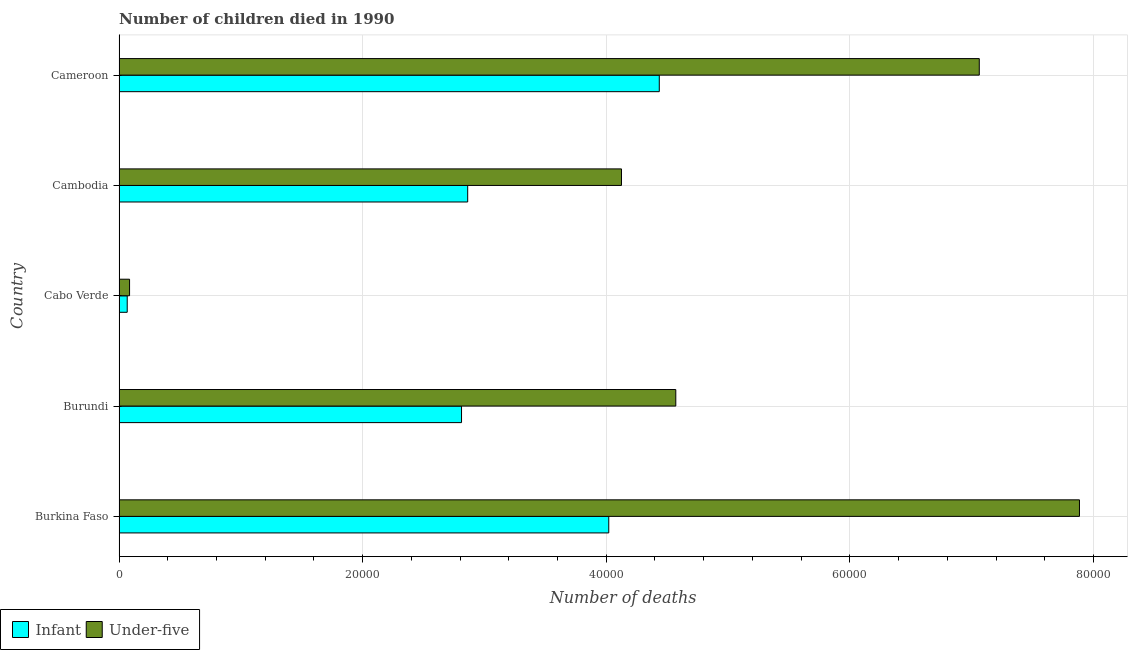How many groups of bars are there?
Your answer should be very brief. 5. Are the number of bars on each tick of the Y-axis equal?
Keep it short and to the point. Yes. What is the label of the 4th group of bars from the top?
Your answer should be very brief. Burundi. In how many cases, is the number of bars for a given country not equal to the number of legend labels?
Make the answer very short. 0. What is the number of infant deaths in Burundi?
Ensure brevity in your answer.  2.81e+04. Across all countries, what is the maximum number of under-five deaths?
Provide a succinct answer. 7.88e+04. Across all countries, what is the minimum number of infant deaths?
Offer a terse response. 671. In which country was the number of under-five deaths maximum?
Your answer should be compact. Burkina Faso. In which country was the number of under-five deaths minimum?
Your answer should be compact. Cabo Verde. What is the total number of infant deaths in the graph?
Ensure brevity in your answer.  1.42e+05. What is the difference between the number of under-five deaths in Burundi and that in Cambodia?
Offer a terse response. 4459. What is the difference between the number of under-five deaths in Burundi and the number of infant deaths in Cabo Verde?
Your response must be concise. 4.50e+04. What is the average number of infant deaths per country?
Your answer should be compact. 2.84e+04. What is the difference between the number of under-five deaths and number of infant deaths in Cambodia?
Give a very brief answer. 1.26e+04. In how many countries, is the number of infant deaths greater than 28000 ?
Provide a succinct answer. 4. What is the ratio of the number of infant deaths in Burkina Faso to that in Cameroon?
Make the answer very short. 0.91. Is the number of infant deaths in Burkina Faso less than that in Cambodia?
Your answer should be compact. No. Is the difference between the number of under-five deaths in Burkina Faso and Cabo Verde greater than the difference between the number of infant deaths in Burkina Faso and Cabo Verde?
Your response must be concise. Yes. What is the difference between the highest and the second highest number of under-five deaths?
Ensure brevity in your answer.  8226. What is the difference between the highest and the lowest number of under-five deaths?
Ensure brevity in your answer.  7.80e+04. What does the 1st bar from the top in Burundi represents?
Offer a terse response. Under-five. What does the 2nd bar from the bottom in Burkina Faso represents?
Ensure brevity in your answer.  Under-five. How many bars are there?
Provide a short and direct response. 10. Are all the bars in the graph horizontal?
Offer a very short reply. Yes. How many countries are there in the graph?
Ensure brevity in your answer.  5. Are the values on the major ticks of X-axis written in scientific E-notation?
Provide a succinct answer. No. Does the graph contain grids?
Make the answer very short. Yes. Where does the legend appear in the graph?
Your answer should be compact. Bottom left. What is the title of the graph?
Offer a very short reply. Number of children died in 1990. What is the label or title of the X-axis?
Your response must be concise. Number of deaths. What is the label or title of the Y-axis?
Keep it short and to the point. Country. What is the Number of deaths of Infant in Burkina Faso?
Give a very brief answer. 4.02e+04. What is the Number of deaths of Under-five in Burkina Faso?
Make the answer very short. 7.88e+04. What is the Number of deaths of Infant in Burundi?
Give a very brief answer. 2.81e+04. What is the Number of deaths in Under-five in Burundi?
Keep it short and to the point. 4.57e+04. What is the Number of deaths of Infant in Cabo Verde?
Give a very brief answer. 671. What is the Number of deaths of Under-five in Cabo Verde?
Make the answer very short. 863. What is the Number of deaths of Infant in Cambodia?
Your answer should be compact. 2.86e+04. What is the Number of deaths in Under-five in Cambodia?
Your response must be concise. 4.12e+04. What is the Number of deaths of Infant in Cameroon?
Ensure brevity in your answer.  4.44e+04. What is the Number of deaths of Under-five in Cameroon?
Your response must be concise. 7.06e+04. Across all countries, what is the maximum Number of deaths in Infant?
Make the answer very short. 4.44e+04. Across all countries, what is the maximum Number of deaths of Under-five?
Make the answer very short. 7.88e+04. Across all countries, what is the minimum Number of deaths of Infant?
Your answer should be compact. 671. Across all countries, what is the minimum Number of deaths in Under-five?
Offer a very short reply. 863. What is the total Number of deaths of Infant in the graph?
Give a very brief answer. 1.42e+05. What is the total Number of deaths in Under-five in the graph?
Provide a succinct answer. 2.37e+05. What is the difference between the Number of deaths in Infant in Burkina Faso and that in Burundi?
Provide a short and direct response. 1.21e+04. What is the difference between the Number of deaths in Under-five in Burkina Faso and that in Burundi?
Offer a terse response. 3.31e+04. What is the difference between the Number of deaths of Infant in Burkina Faso and that in Cabo Verde?
Your answer should be compact. 3.95e+04. What is the difference between the Number of deaths in Under-five in Burkina Faso and that in Cabo Verde?
Your answer should be very brief. 7.80e+04. What is the difference between the Number of deaths of Infant in Burkina Faso and that in Cambodia?
Ensure brevity in your answer.  1.16e+04. What is the difference between the Number of deaths in Under-five in Burkina Faso and that in Cambodia?
Offer a very short reply. 3.76e+04. What is the difference between the Number of deaths of Infant in Burkina Faso and that in Cameroon?
Give a very brief answer. -4148. What is the difference between the Number of deaths in Under-five in Burkina Faso and that in Cameroon?
Keep it short and to the point. 8226. What is the difference between the Number of deaths in Infant in Burundi and that in Cabo Verde?
Your response must be concise. 2.74e+04. What is the difference between the Number of deaths of Under-five in Burundi and that in Cabo Verde?
Ensure brevity in your answer.  4.48e+04. What is the difference between the Number of deaths of Infant in Burundi and that in Cambodia?
Provide a succinct answer. -505. What is the difference between the Number of deaths of Under-five in Burundi and that in Cambodia?
Give a very brief answer. 4459. What is the difference between the Number of deaths of Infant in Burundi and that in Cameroon?
Your answer should be compact. -1.62e+04. What is the difference between the Number of deaths in Under-five in Burundi and that in Cameroon?
Your answer should be very brief. -2.49e+04. What is the difference between the Number of deaths in Infant in Cabo Verde and that in Cambodia?
Ensure brevity in your answer.  -2.80e+04. What is the difference between the Number of deaths of Under-five in Cabo Verde and that in Cambodia?
Offer a terse response. -4.04e+04. What is the difference between the Number of deaths of Infant in Cabo Verde and that in Cameroon?
Provide a short and direct response. -4.37e+04. What is the difference between the Number of deaths in Under-five in Cabo Verde and that in Cameroon?
Offer a terse response. -6.98e+04. What is the difference between the Number of deaths in Infant in Cambodia and that in Cameroon?
Give a very brief answer. -1.57e+04. What is the difference between the Number of deaths in Under-five in Cambodia and that in Cameroon?
Provide a succinct answer. -2.94e+04. What is the difference between the Number of deaths of Infant in Burkina Faso and the Number of deaths of Under-five in Burundi?
Your answer should be very brief. -5503. What is the difference between the Number of deaths of Infant in Burkina Faso and the Number of deaths of Under-five in Cabo Verde?
Give a very brief answer. 3.93e+04. What is the difference between the Number of deaths in Infant in Burkina Faso and the Number of deaths in Under-five in Cambodia?
Your answer should be very brief. -1044. What is the difference between the Number of deaths of Infant in Burkina Faso and the Number of deaths of Under-five in Cameroon?
Ensure brevity in your answer.  -3.04e+04. What is the difference between the Number of deaths of Infant in Burundi and the Number of deaths of Under-five in Cabo Verde?
Make the answer very short. 2.73e+04. What is the difference between the Number of deaths of Infant in Burundi and the Number of deaths of Under-five in Cambodia?
Keep it short and to the point. -1.31e+04. What is the difference between the Number of deaths in Infant in Burundi and the Number of deaths in Under-five in Cameroon?
Offer a very short reply. -4.25e+04. What is the difference between the Number of deaths of Infant in Cabo Verde and the Number of deaths of Under-five in Cambodia?
Your answer should be very brief. -4.06e+04. What is the difference between the Number of deaths of Infant in Cabo Verde and the Number of deaths of Under-five in Cameroon?
Ensure brevity in your answer.  -7.00e+04. What is the difference between the Number of deaths in Infant in Cambodia and the Number of deaths in Under-five in Cameroon?
Keep it short and to the point. -4.20e+04. What is the average Number of deaths of Infant per country?
Make the answer very short. 2.84e+04. What is the average Number of deaths in Under-five per country?
Provide a short and direct response. 4.75e+04. What is the difference between the Number of deaths of Infant and Number of deaths of Under-five in Burkina Faso?
Your answer should be compact. -3.86e+04. What is the difference between the Number of deaths in Infant and Number of deaths in Under-five in Burundi?
Make the answer very short. -1.76e+04. What is the difference between the Number of deaths of Infant and Number of deaths of Under-five in Cabo Verde?
Your response must be concise. -192. What is the difference between the Number of deaths in Infant and Number of deaths in Under-five in Cambodia?
Your response must be concise. -1.26e+04. What is the difference between the Number of deaths of Infant and Number of deaths of Under-five in Cameroon?
Offer a terse response. -2.63e+04. What is the ratio of the Number of deaths of Infant in Burkina Faso to that in Burundi?
Your answer should be compact. 1.43. What is the ratio of the Number of deaths of Under-five in Burkina Faso to that in Burundi?
Ensure brevity in your answer.  1.73. What is the ratio of the Number of deaths of Infant in Burkina Faso to that in Cabo Verde?
Offer a very short reply. 59.92. What is the ratio of the Number of deaths in Under-five in Burkina Faso to that in Cabo Verde?
Your answer should be compact. 91.37. What is the ratio of the Number of deaths in Infant in Burkina Faso to that in Cambodia?
Make the answer very short. 1.4. What is the ratio of the Number of deaths in Under-five in Burkina Faso to that in Cambodia?
Provide a succinct answer. 1.91. What is the ratio of the Number of deaths in Infant in Burkina Faso to that in Cameroon?
Provide a short and direct response. 0.91. What is the ratio of the Number of deaths in Under-five in Burkina Faso to that in Cameroon?
Keep it short and to the point. 1.12. What is the ratio of the Number of deaths in Infant in Burundi to that in Cabo Verde?
Give a very brief answer. 41.9. What is the ratio of the Number of deaths in Under-five in Burundi to that in Cabo Verde?
Give a very brief answer. 52.96. What is the ratio of the Number of deaths of Infant in Burundi to that in Cambodia?
Offer a terse response. 0.98. What is the ratio of the Number of deaths of Under-five in Burundi to that in Cambodia?
Your response must be concise. 1.11. What is the ratio of the Number of deaths of Infant in Burundi to that in Cameroon?
Your answer should be compact. 0.63. What is the ratio of the Number of deaths of Under-five in Burundi to that in Cameroon?
Make the answer very short. 0.65. What is the ratio of the Number of deaths of Infant in Cabo Verde to that in Cambodia?
Make the answer very short. 0.02. What is the ratio of the Number of deaths in Under-five in Cabo Verde to that in Cambodia?
Your answer should be compact. 0.02. What is the ratio of the Number of deaths in Infant in Cabo Verde to that in Cameroon?
Keep it short and to the point. 0.02. What is the ratio of the Number of deaths of Under-five in Cabo Verde to that in Cameroon?
Ensure brevity in your answer.  0.01. What is the ratio of the Number of deaths in Infant in Cambodia to that in Cameroon?
Your answer should be very brief. 0.65. What is the ratio of the Number of deaths in Under-five in Cambodia to that in Cameroon?
Provide a succinct answer. 0.58. What is the difference between the highest and the second highest Number of deaths in Infant?
Your response must be concise. 4148. What is the difference between the highest and the second highest Number of deaths in Under-five?
Keep it short and to the point. 8226. What is the difference between the highest and the lowest Number of deaths of Infant?
Make the answer very short. 4.37e+04. What is the difference between the highest and the lowest Number of deaths in Under-five?
Keep it short and to the point. 7.80e+04. 